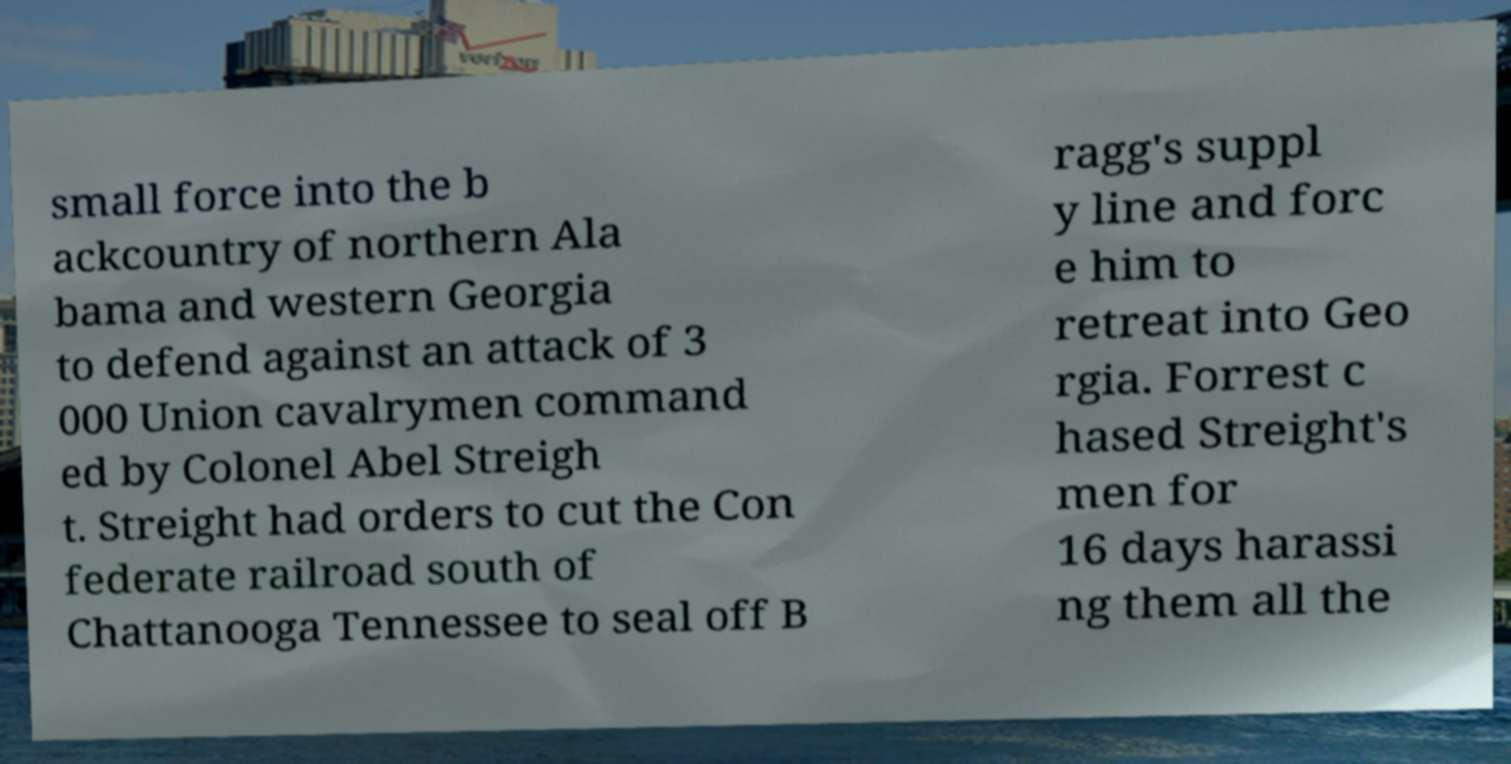I need the written content from this picture converted into text. Can you do that? small force into the b ackcountry of northern Ala bama and western Georgia to defend against an attack of 3 000 Union cavalrymen command ed by Colonel Abel Streigh t. Streight had orders to cut the Con federate railroad south of Chattanooga Tennessee to seal off B ragg's suppl y line and forc e him to retreat into Geo rgia. Forrest c hased Streight's men for 16 days harassi ng them all the 